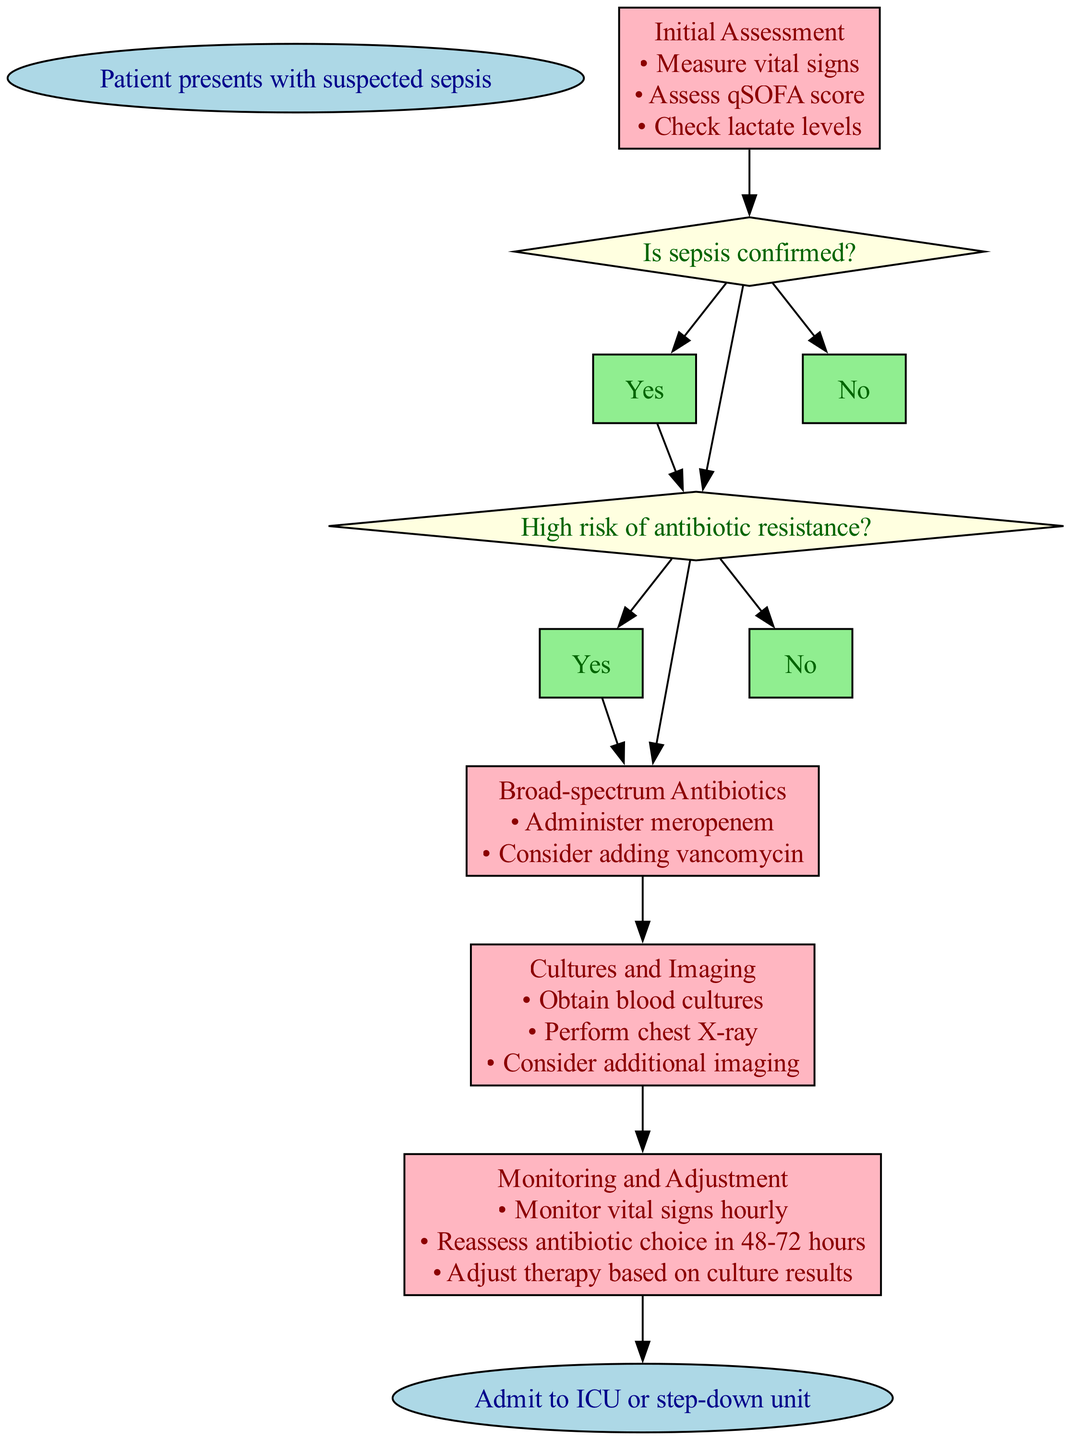What is the first action in the initial assessment? The diagram indicates that the first action during the "Initial Assessment" step is to "Measure vital signs." This is one of the listed actions under that specific step in the pathway.
Answer: Measure vital signs How many steps are there in the diagram? The diagram contains a total of six steps, including "Initial Assessment," "Sepsis Confirmed," "Antibiotic Resistance Risk," "Broad-spectrum Antibiotics," "Cultures and Imaging," and "Monitoring and Adjustment." Each of these steps contributes to the clinical pathway for handling suspected sepsis.
Answer: Six steps What do you do if sepsis is confirmed? According to the diagram, if sepsis is confirmed, the next step is to assess whether there is a high risk of antibiotic resistance. This decision leads to the broader protocol for handling the case based on resistance risk.
Answer: Antibiotic Resistance Risk What medication is administered if there is a high risk of antibiotic resistance? The diagram specifies that if there is a high risk of antibiotic resistance, the clinician should administer "meropenem" and may consider adding "vancomycin." This is a critical part of the pathway for treating suspected sepsis in such cases.
Answer: Meropenem What is the next step after monitoring and adjustment? The diagram indicates that the final step after "Monitoring and Adjustment" is to "Admit to ICU or step-down unit." This represents the concluding action in the clinical pathway after the necessary monitoring and adjustments of the treatment plan.
Answer: Admit to ICU or step-down unit What action is performed during the "Cultures and Imaging" step? According to the diagram, during the "Cultures and Imaging" step, actions include obtaining blood cultures, performing a chest X-ray, and considering additional imaging. These actions are essential for diagnosing and managing the patient's condition.
Answer: Obtain blood cultures, perform chest X-ray, consider additional imaging What happens if sepsis is not confirmed? The diagram shows that if sepsis is not confirmed, the next step leads to an "Alternative Diagnosis," indicating that the treatment will shift to considering other possible medical conditions.
Answer: Alternative Diagnosis In the "Monitoring and Adjustment" step, how frequently are vital signs monitored? The diagram specifies that vital signs should be monitored on an hourly basis during the "Monitoring and Adjustment" step. This frequency is crucial for ensuring timely interventions based on the patient's condition.
Answer: Hourly 